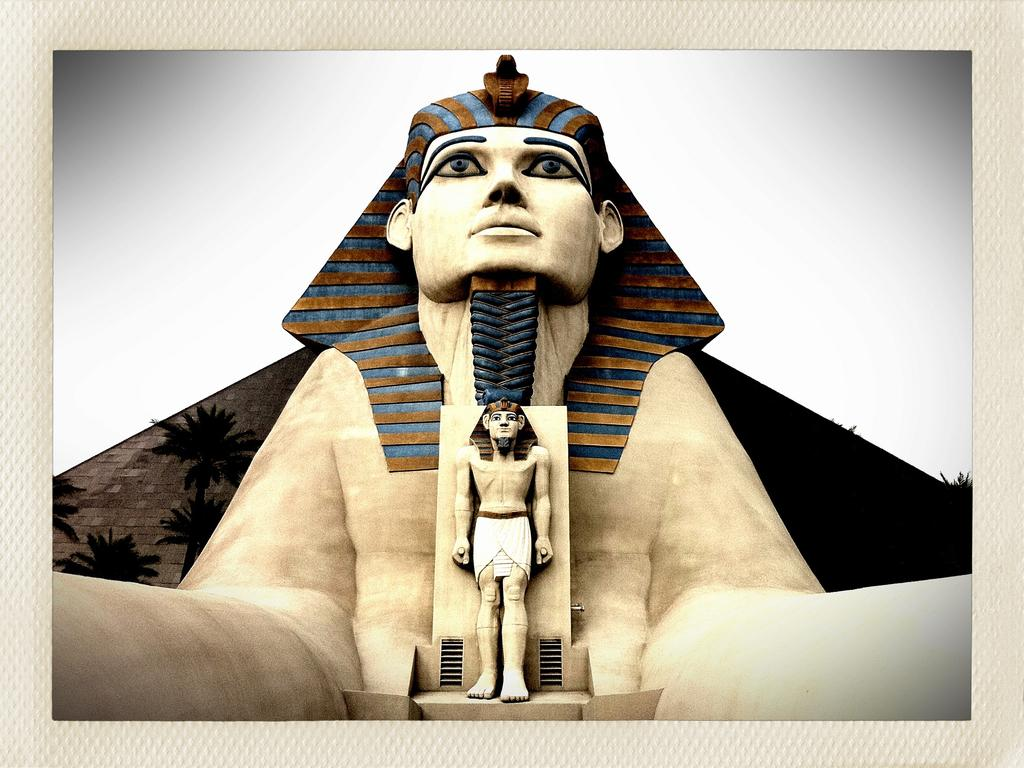What type of objects are depicted as the main subjects in the image? There are statues of people in the image. What other natural elements can be seen in the image? There are trees in the image. What can be seen in the distance in the image? The sky is visible in the background of the image. What type of approval is being sought in the image? There is no indication in the image that approval is being sought; it features statues of people, trees, and the sky. What scene is being depicted in the image? The image does not depict a specific scene; it simply shows statues of people, trees, and the sky. 